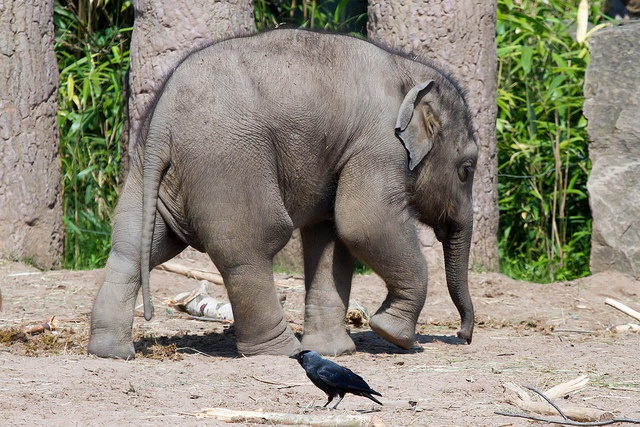Describe the objects in this image and their specific colors. I can see elephant in darkgray, gray, and black tones and bird in darkgray, black, navy, blue, and gray tones in this image. 